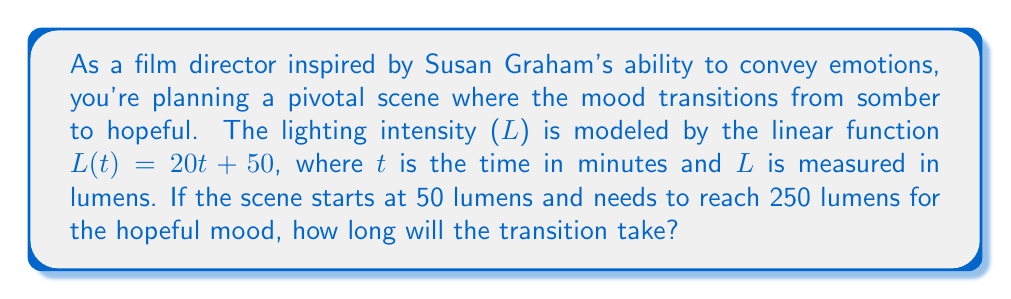Can you solve this math problem? Let's approach this step-by-step:

1) We're given the linear function: $L(t) = 20t + 50$
   Where L is the lighting intensity in lumens and t is the time in minutes.

2) We know two points:
   - Start: 50 lumens
   - End: 250 lumens

3) To find the time, we need to solve the equation:
   $250 = 20t + 50$

4) Subtract 50 from both sides:
   $200 = 20t$

5) Divide both sides by 20:
   $10 = t$

Therefore, it will take 10 minutes for the lighting to transition from 50 to 250 lumens, creating the desired mood change from somber to hopeful.
Answer: 10 minutes 